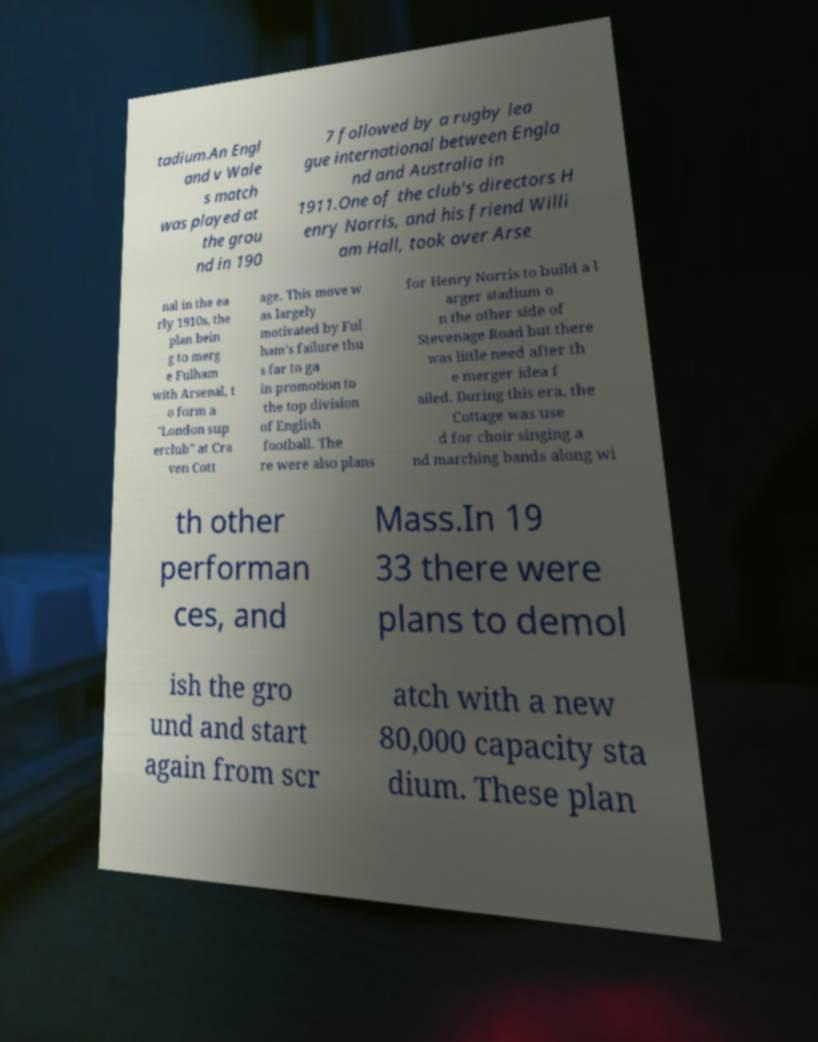I need the written content from this picture converted into text. Can you do that? tadium.An Engl and v Wale s match was played at the grou nd in 190 7 followed by a rugby lea gue international between Engla nd and Australia in 1911.One of the club's directors H enry Norris, and his friend Willi am Hall, took over Arse nal in the ea rly 1910s, the plan bein g to merg e Fulham with Arsenal, t o form a "London sup erclub" at Cra ven Cott age. This move w as largely motivated by Ful ham's failure thu s far to ga in promotion to the top division of English football. The re were also plans for Henry Norris to build a l arger stadium o n the other side of Stevenage Road but there was little need after th e merger idea f ailed. During this era, the Cottage was use d for choir singing a nd marching bands along wi th other performan ces, and Mass.In 19 33 there were plans to demol ish the gro und and start again from scr atch with a new 80,000 capacity sta dium. These plan 